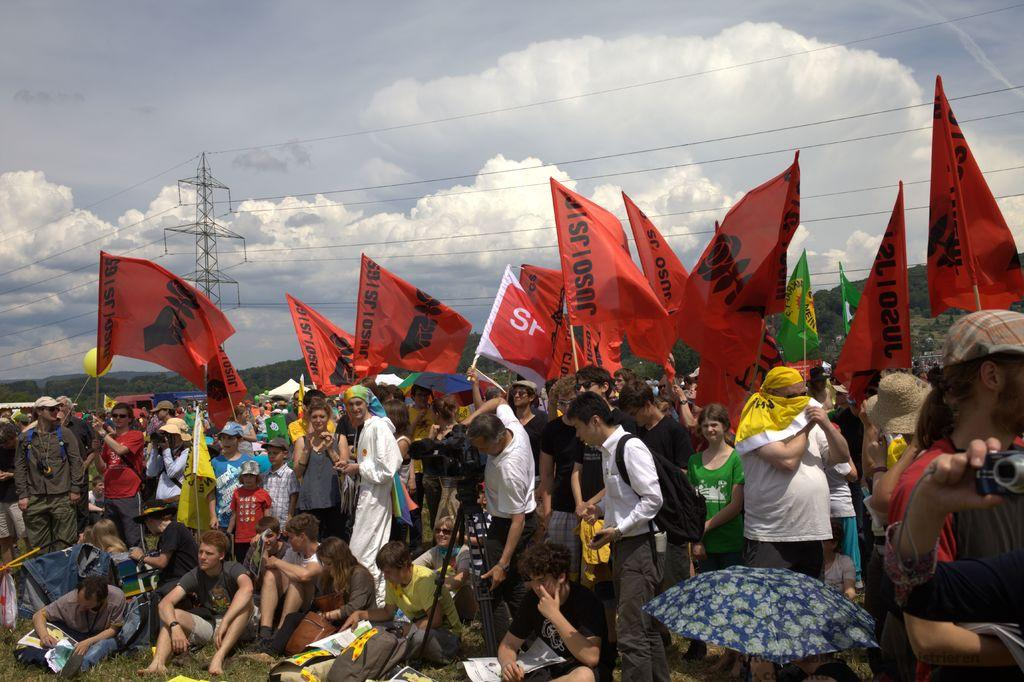What are the people in the image doing? Some people are standing and some are sitting in the center of the image. What can be seen in the background of the image? There are flags, wires, a tower, hills, and the sky visible in the background of the image. Can you describe the umbrella in the image? Yes, there is an umbrella in the image. How many tickets are visible in the image? There are no tickets present in the image. What type of leg is visible on the hill in the background? There is no leg visible in the image, and the hill is not a living organism with legs. 